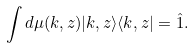Convert formula to latex. <formula><loc_0><loc_0><loc_500><loc_500>\int d \mu ( k , z ) | k , z \rangle \langle k , z | = \hat { 1 } .</formula> 